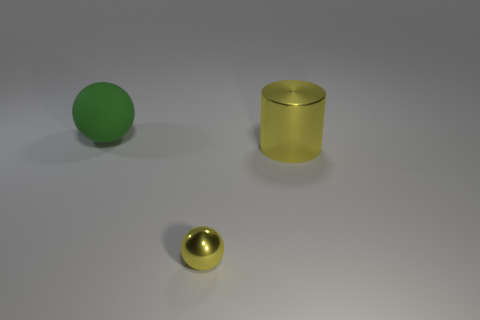Are there any other things that are the same size as the yellow metal ball?
Provide a succinct answer. No. Do the cylinder and the metallic ball have the same size?
Give a very brief answer. No. The thing that is behind the yellow ball and in front of the green matte ball is what color?
Make the answer very short. Yellow. What is the shape of the big yellow thing that is the same material as the yellow ball?
Make the answer very short. Cylinder. How many spheres are behind the tiny yellow object and in front of the large yellow cylinder?
Your answer should be compact. 0. Are there any big yellow objects on the left side of the tiny yellow thing?
Provide a succinct answer. No. There is a yellow metallic thing that is behind the small thing; is it the same shape as the yellow metal thing that is left of the big cylinder?
Offer a very short reply. No. What number of objects are big cylinders or yellow objects in front of the yellow cylinder?
Your answer should be very brief. 2. How many other objects are the same shape as the big yellow object?
Provide a short and direct response. 0. Does the big object on the right side of the big green rubber object have the same material as the small sphere?
Keep it short and to the point. Yes. 